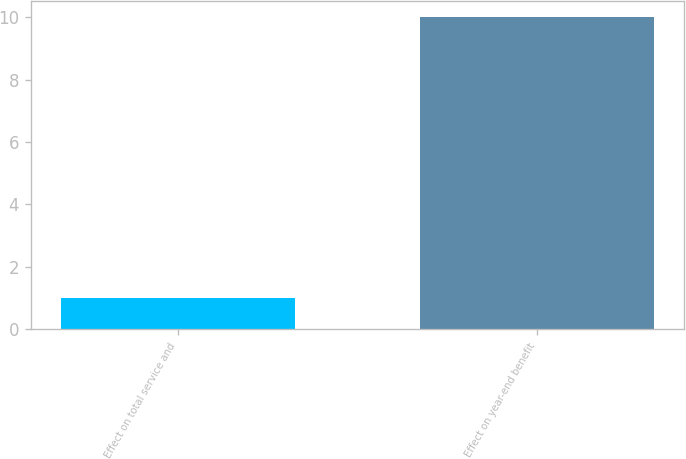Convert chart. <chart><loc_0><loc_0><loc_500><loc_500><bar_chart><fcel>Effect on total service and<fcel>Effect on year-end benefit<nl><fcel>1<fcel>10<nl></chart> 